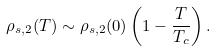Convert formula to latex. <formula><loc_0><loc_0><loc_500><loc_500>\rho _ { s , 2 } ( T ) \sim \rho _ { s , 2 } ( 0 ) \left ( 1 - \frac { T } { T _ { c } } \right ) .</formula> 